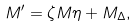<formula> <loc_0><loc_0><loc_500><loc_500>M ^ { \prime } = \zeta M \eta + M _ { \Delta } ,</formula> 